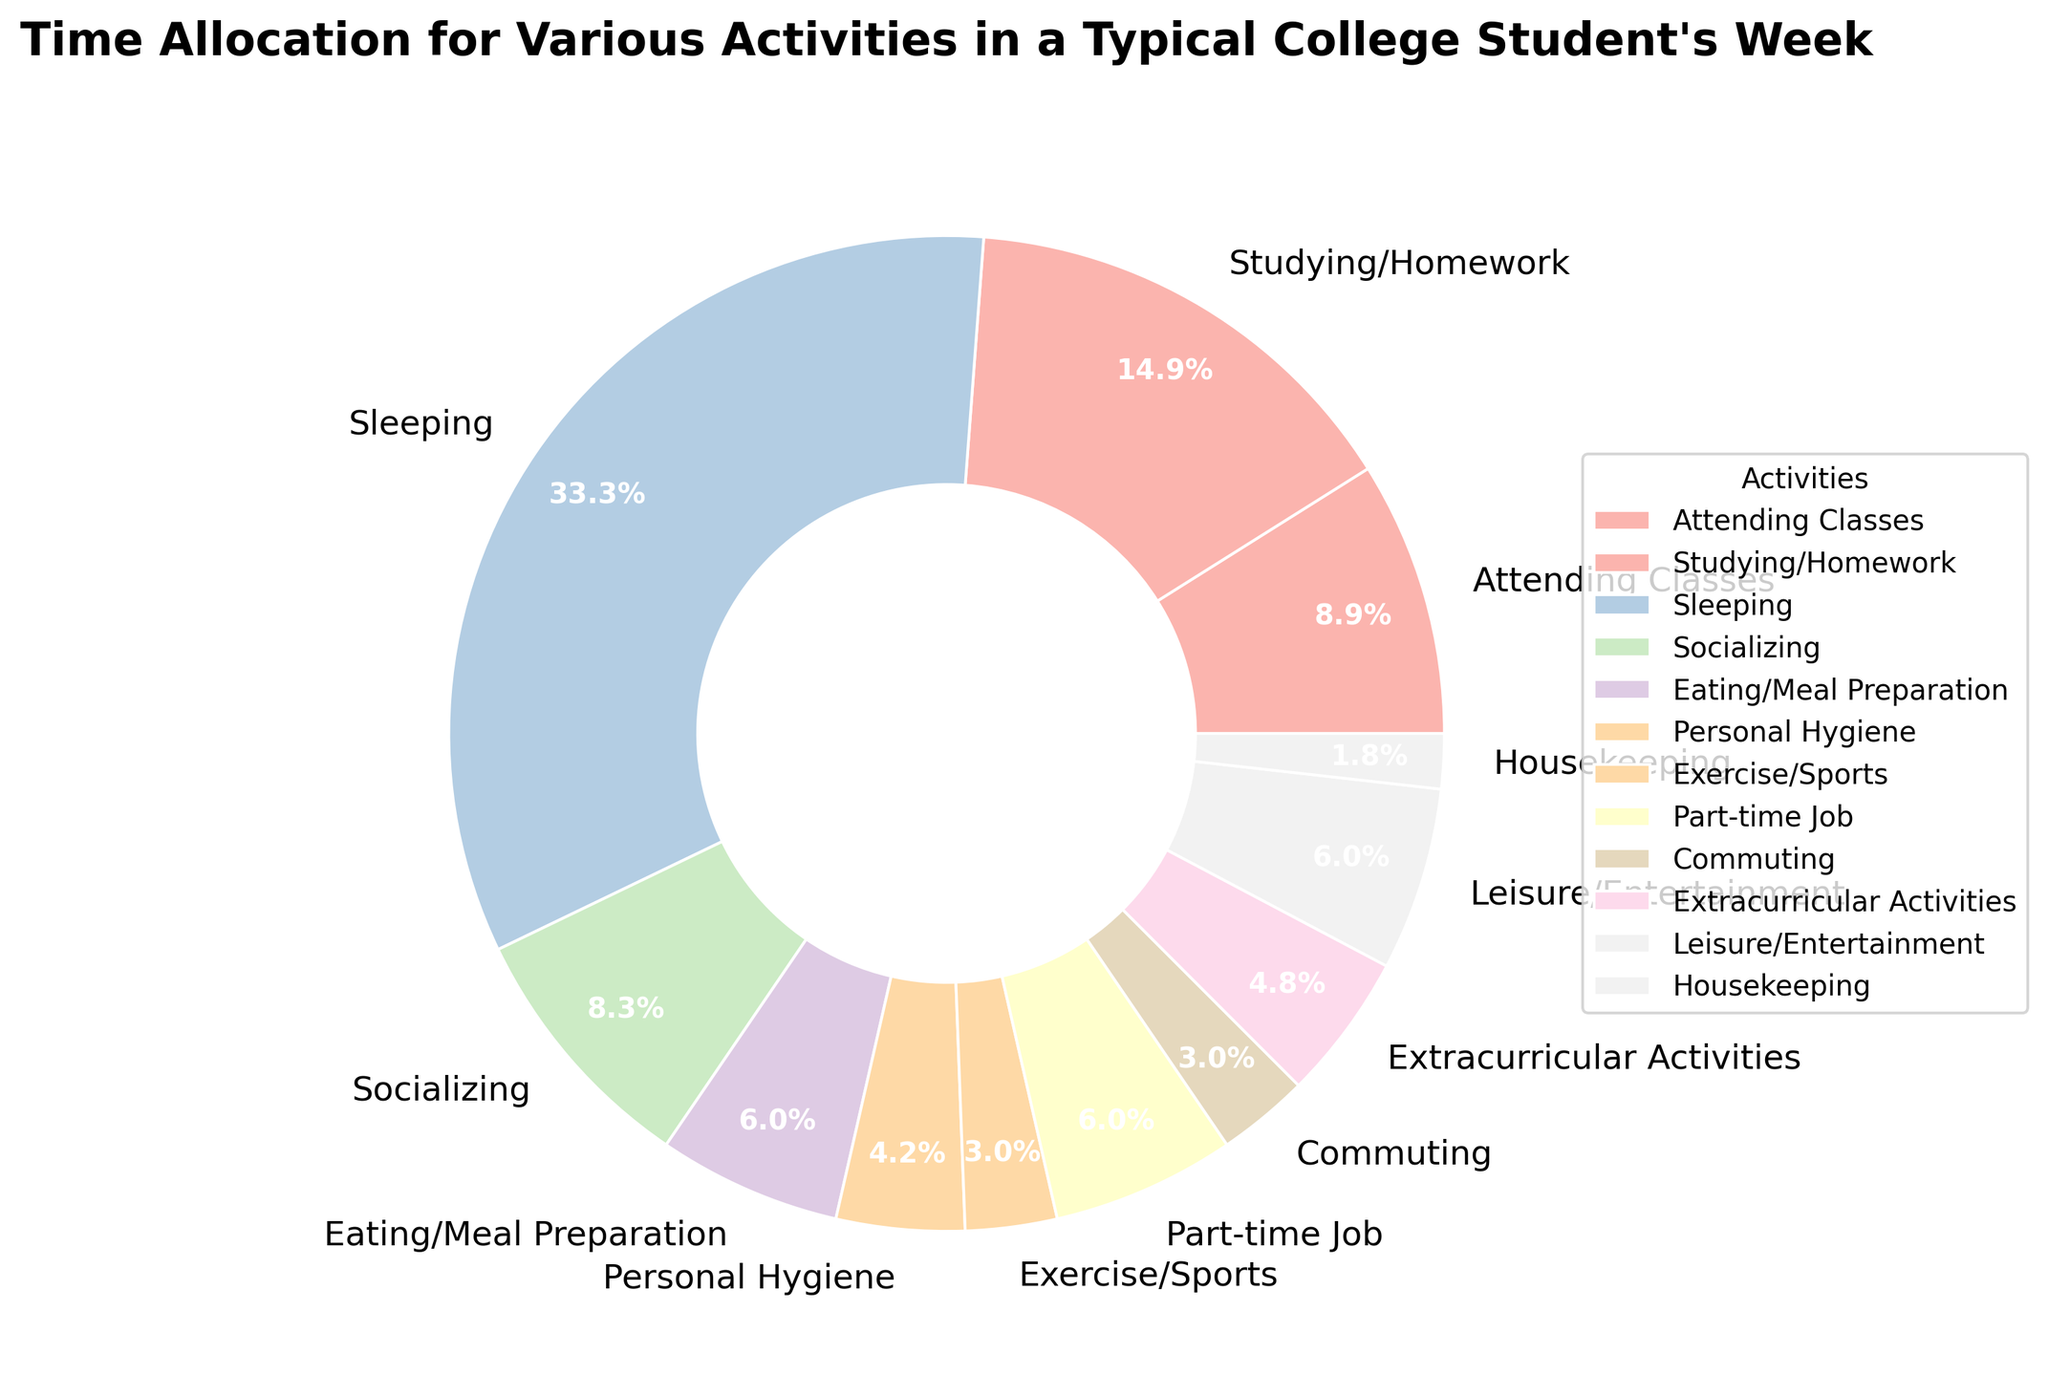What percentage of time is spent on Attending Classes and Studying/Homework combined? Attending Classes accounts for 15 hours and Studying/Homework accounts for 25 hours. Adding these together gives 15 + 25 = 40 hours. In the pie chart, 40 hours of a total of 168 hours in a week accounts for (40/168) * 100 ≈ 23.8%.
Answer: 23.8% How does the time spent on Sleeping compare to the time spent on Part-time Job and Exercise/Sports combined? Time spent on Sleeping is 56 hours. Combining the hours for Part-time Job and Exercise/Sports gives 10 + 5 = 15 hours. Comparing these two, 56 hours is greater than 15 hours.
Answer: Sleeping > Part-time Job + Exercise/Sports Which activity, Socializing or Extracurricular Activities, takes up more time? Socializing accounts for 14 hours and Extracurricular Activities account for 8 hours. Comparing these two, 14 hours is greater than 8 hours.
Answer: Socializing What is the visual difference in the section sizes between Eating/Meal Preparation and Housekeeping? The sector for Eating/Meal Preparation (10 hours) is visually larger than the sector for Housekeeping (3 hours). This is because 10 hours is more than 3 hours, so the wedge representing Eating/Meal Preparation occupies a larger fraction of the pie.
Answer: Eating/Meal Preparation > Housekeeping What is the total time allocated to Leisure/Entertainment, Exercise/Sports, and Personal Hygiene? Adding the hours for these activities gives 10 (Leisure/Entertainment) + 5 (Exercise/Sports) + 7 (Personal Hygiene) = 22 hours.
Answer: 22 hours Is the time spent on Commuting equal to time spent on Exercise/Sports? The time spent on Commuting is 5 hours, and the time spent on Exercise/Sports is also 5 hours. Therefore, both are equal.
Answer: Equal Which activity has the smallest allocation of time? Housekeeping has the smallest allocation of time with only 3 hours.
Answer: Housekeeping How does time spent on Studying/Homework compare to time spent Sleeping in terms of percentage? Time spent on Studying/Homework is 25 hours, and time spent Sleeping is 56 hours. In percentage, Studying/Homework is (25/168) * 100 ≈ 14.9%, and Sleeping is (56/168) * 100 ≈ 33.3%. Therefore, the time spent on Sleeping is significantly higher.
Answer: Sleeping > Studying/Homework Which activity consumes around 10% of the time? The activity that consumes around 10% of the time is Eating/Meal Preparation, which accounts for 10 hours. In percentage terms, it is (10/168) * 100 ≈ 6%, and Leisure/Entertainment also accounts for 10 hours, approximately the same percentage.
Answer: Eating/Meal Preparation, Leisure/Entertainment 